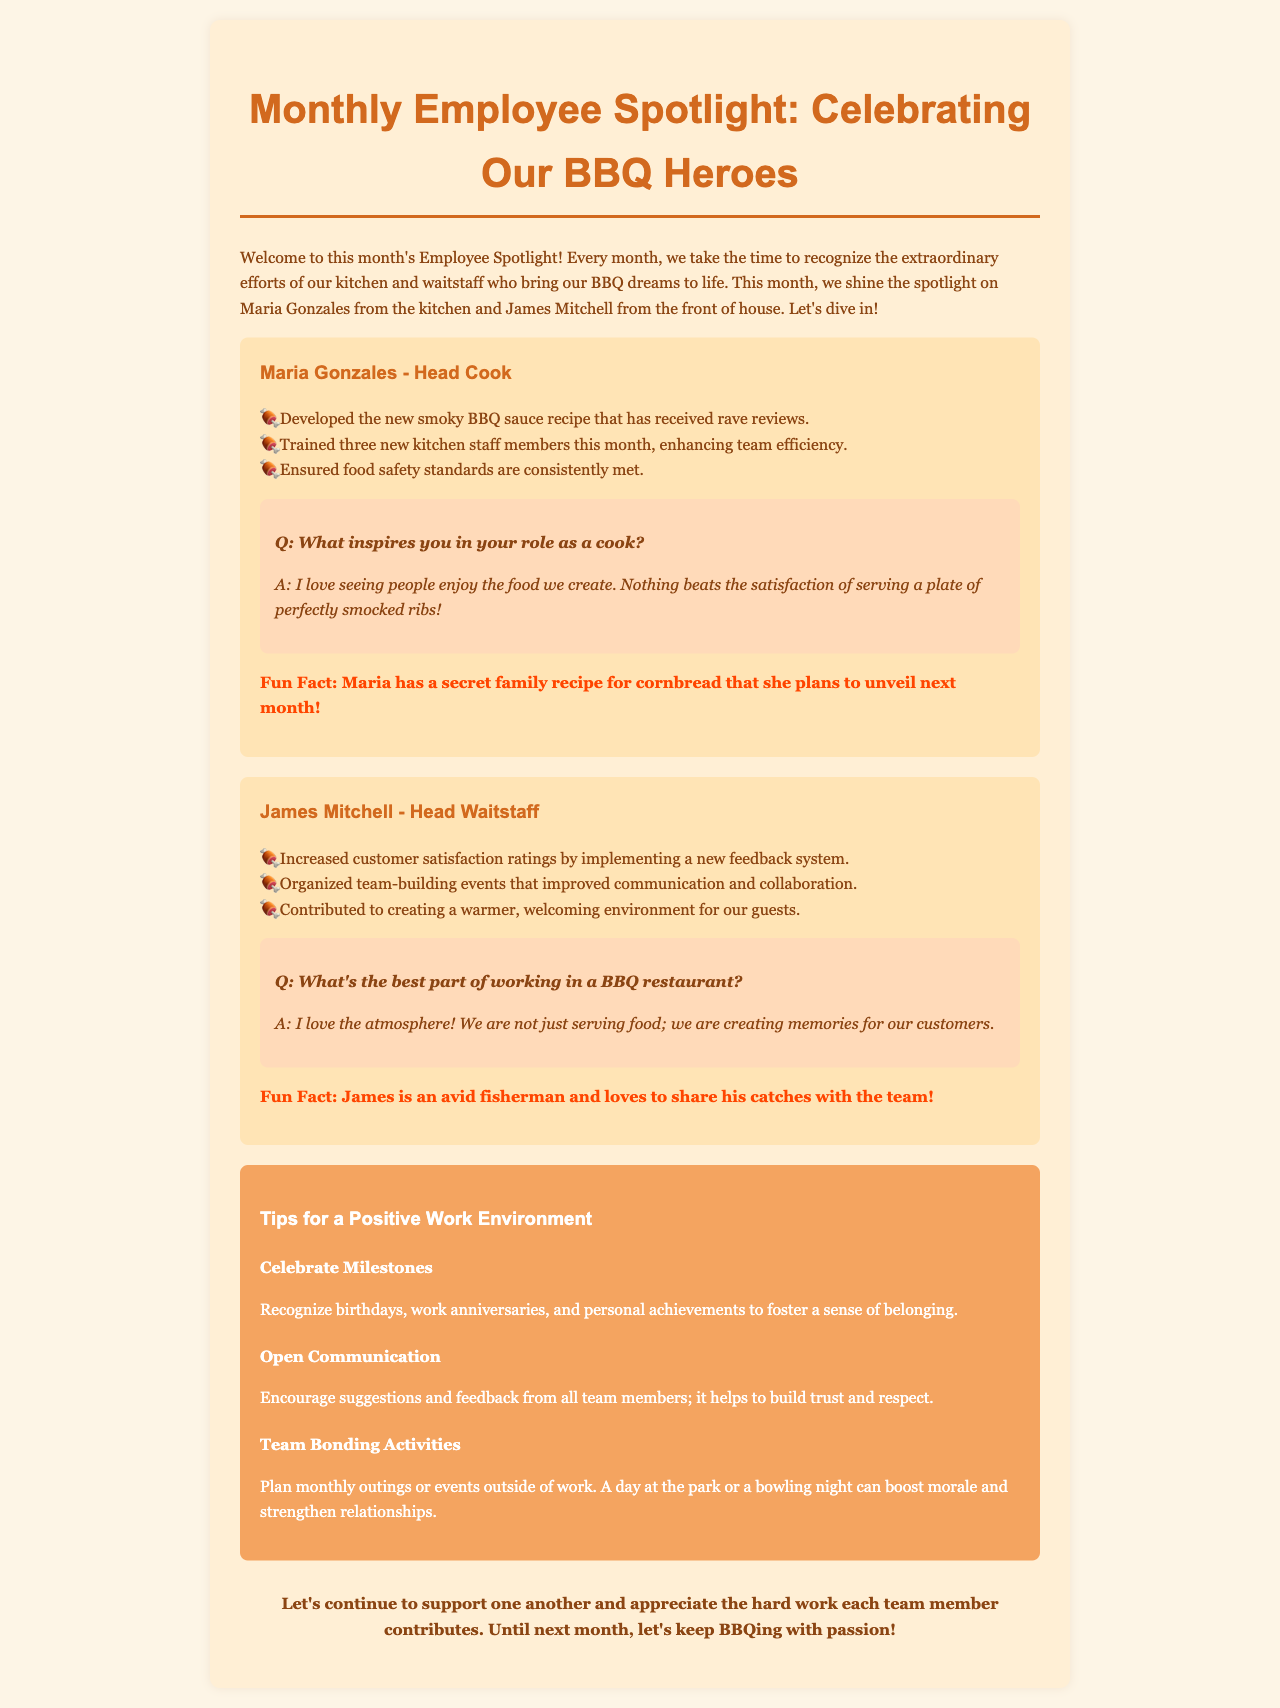What is the name of the head cook? The document specifically mentions the head cook as Maria Gonzales.
Answer: Maria Gonzales How many new kitchen staff members did Maria train? The document states that Maria trained three new kitchen staff members.
Answer: three What is the main focus of James's contributions? James's contributions are specifically focused on increasing customer satisfaction.
Answer: customer satisfaction What fun fact is mentioned about Maria? The document states that Maria has a secret family recipe for cornbread.
Answer: secret family recipe for cornbread What type of system did James implement to improve ratings? The document mentions that James implemented a new feedback system for customer satisfaction ratings.
Answer: feedback system What is one of the tips for fostering a positive work environment? The document suggests celebrating milestones as a tip for fostering a positive work environment.
Answer: celebrate milestones Who organized team-building events? The document highlights that James organized team-building events.
Answer: James What does Maria love seeing in her role as a cook? The document mentions that Maria loves seeing people enjoy the food they create.
Answer: people enjoy the food What color is the background of the newsletter? The document describes the background color of the newsletter as #FDF5E6.
Answer: #FDF5E6 